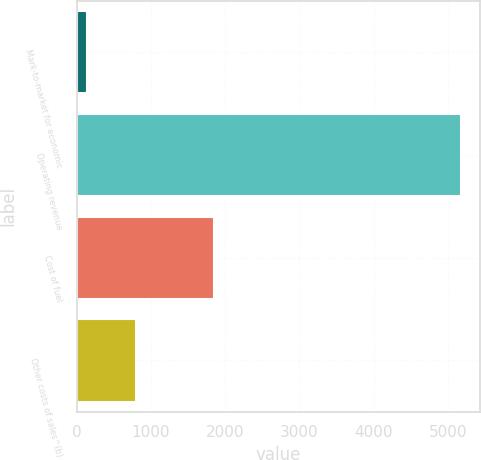Convert chart. <chart><loc_0><loc_0><loc_500><loc_500><bar_chart><fcel>Mark-to-market for economic<fcel>Operating revenue<fcel>Cost of fuel<fcel>Other costs of sales^(b)<nl><fcel>142<fcel>5179<fcel>1852<fcel>797<nl></chart> 